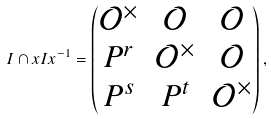<formula> <loc_0><loc_0><loc_500><loc_500>I \cap x I x ^ { - 1 } = \begin{pmatrix} \mathcal { O } ^ { \times } & \mathcal { O } & \mathcal { O } \\ P ^ { r } & \mathcal { O } ^ { \times } & \mathcal { O } \\ P ^ { s } & P ^ { t } & \mathcal { O } ^ { \times } \end{pmatrix} ,</formula> 